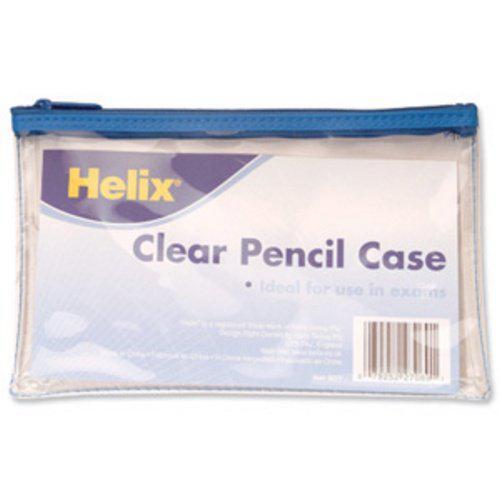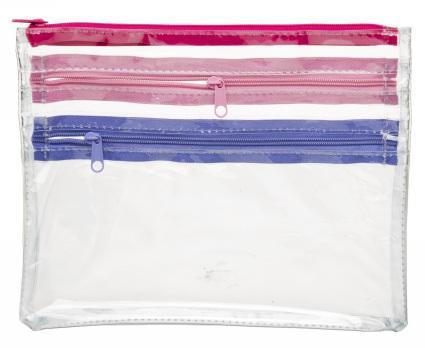The first image is the image on the left, the second image is the image on the right. For the images displayed, is the sentence "One clear pencil case has only a blue zipper on top, and one pencil case has at least a pink zipper across the top." factually correct? Answer yes or no. Yes. The first image is the image on the left, the second image is the image on the right. Considering the images on both sides, is "There are 2 pencil cases, each with 1 zipper." valid? Answer yes or no. No. 